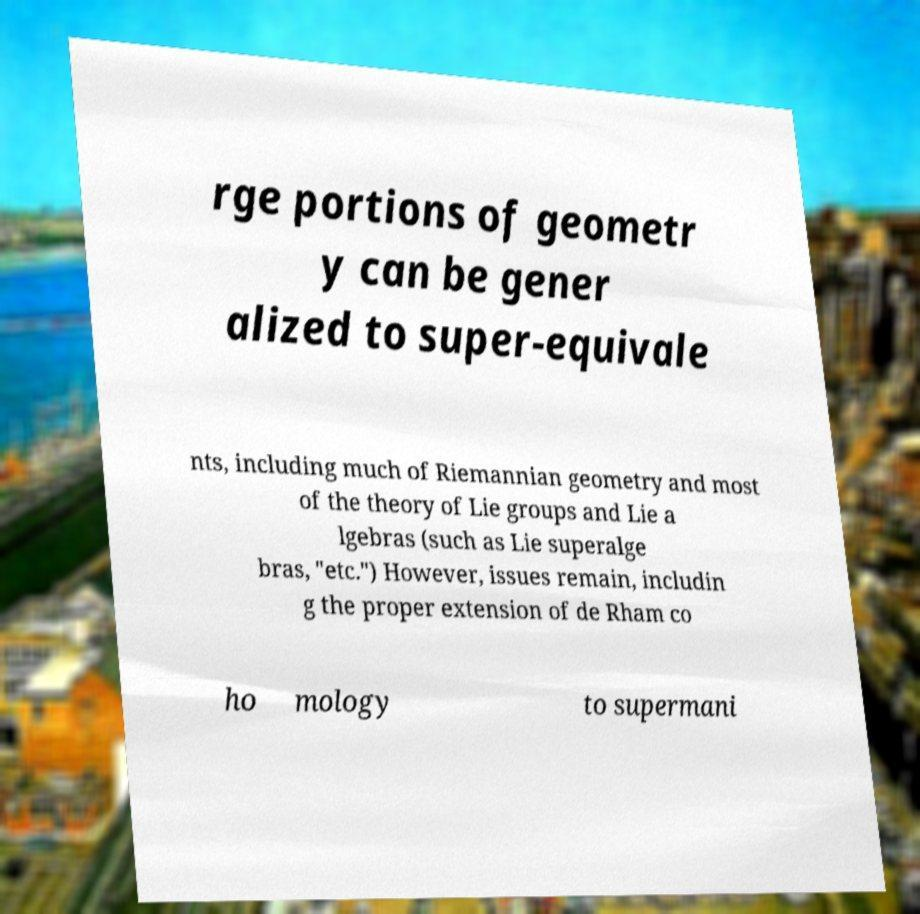Can you read and provide the text displayed in the image?This photo seems to have some interesting text. Can you extract and type it out for me? rge portions of geometr y can be gener alized to super-equivale nts, including much of Riemannian geometry and most of the theory of Lie groups and Lie a lgebras (such as Lie superalge bras, "etc.") However, issues remain, includin g the proper extension of de Rham co ho mology to supermani 